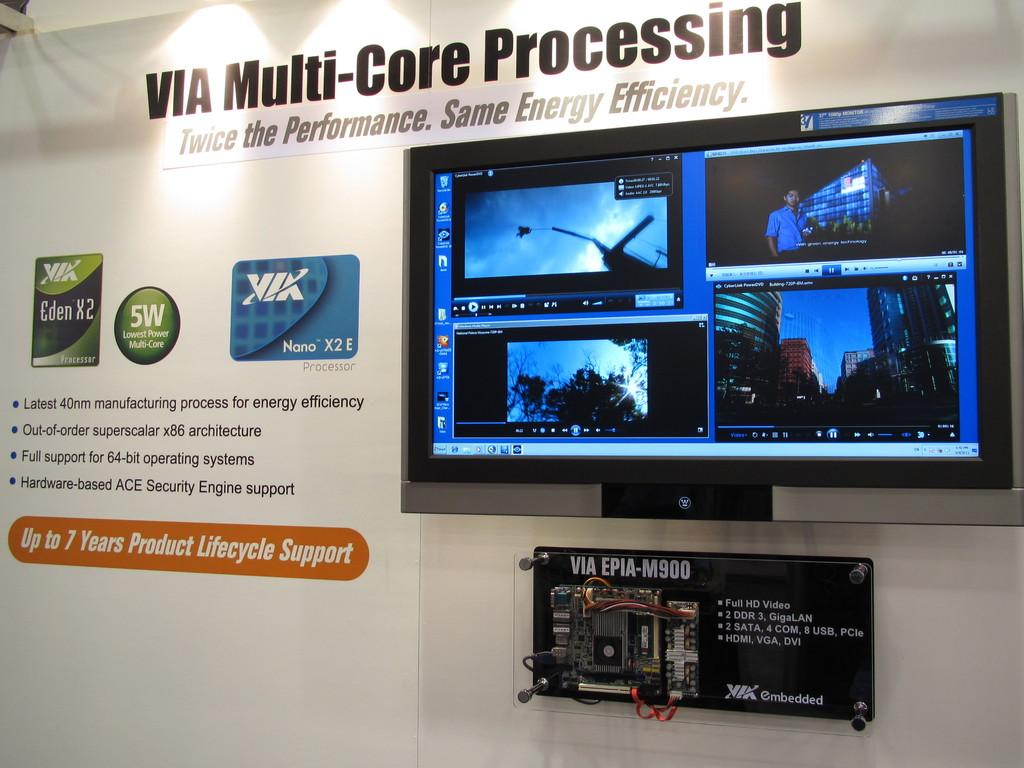What is on the wall in the image? There is a TV screen on the wall in the image. What else can be seen in the image besides the TV screen? There is another object in the image. Is there any text visible in the image? Yes, there is some text visible in the image. What type of twig is the farmer holding in the image? There is no farmer or twig present in the image. Where is the mailbox located in the image? There is no mailbox present in the image. 